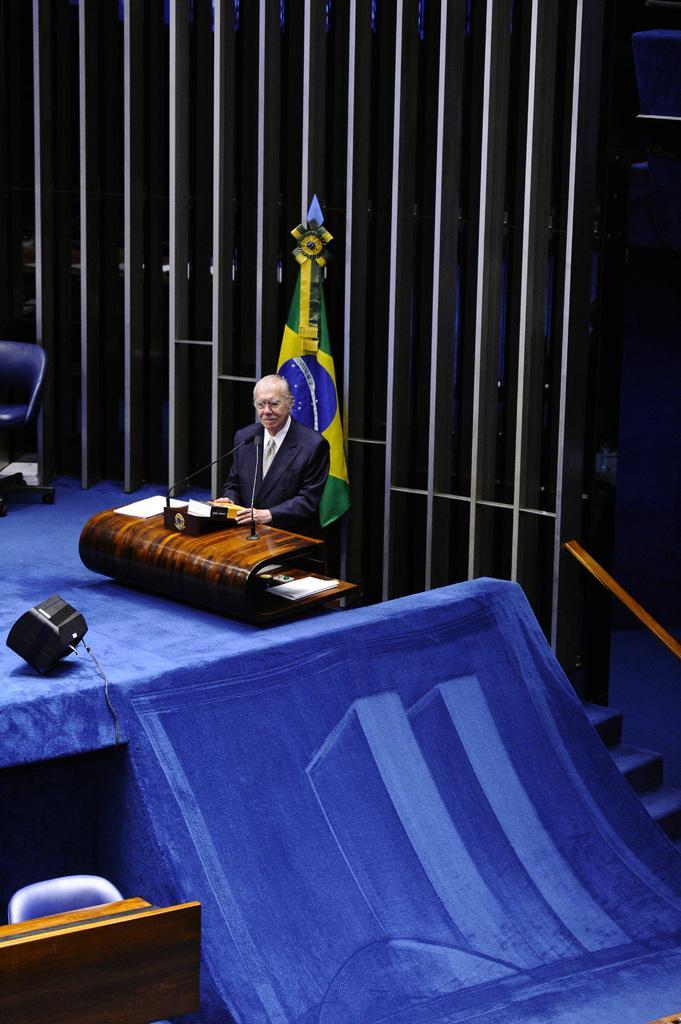Can you describe this image briefly? In this image in the center there is one person who is standing in front of him there is one mike and table. On the table there are some papers, at the bottom there is some objects and a speaker. In the background there is a wall and one chair, on the right side there are some stairs. 